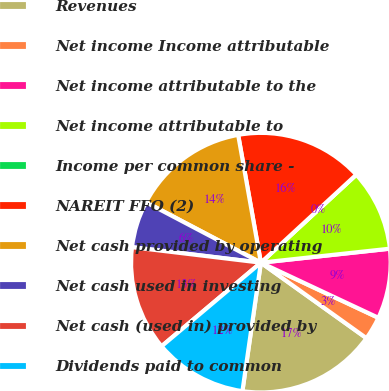Convert chart to OTSL. <chart><loc_0><loc_0><loc_500><loc_500><pie_chart><fcel>Revenues<fcel>Net income Income attributable<fcel>Net income attributable to the<fcel>Net income attributable to<fcel>Income per common share -<fcel>NAREIT FFO (2)<fcel>Net cash provided by operating<fcel>Net cash used in investing<fcel>Net cash (used in) provided by<fcel>Dividends paid to common<nl><fcel>17.39%<fcel>2.9%<fcel>8.7%<fcel>10.14%<fcel>0.0%<fcel>15.94%<fcel>14.49%<fcel>5.8%<fcel>13.04%<fcel>11.59%<nl></chart> 